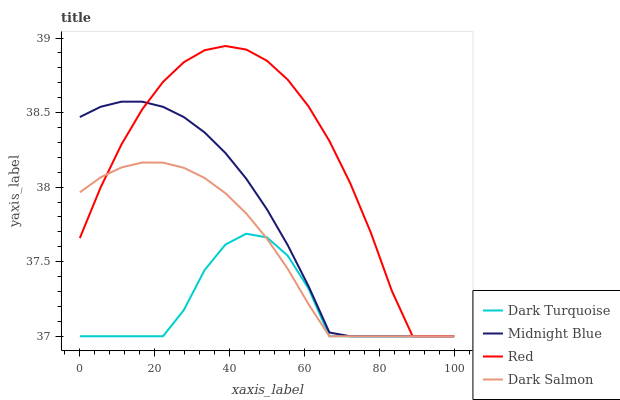Does Dark Turquoise have the minimum area under the curve?
Answer yes or no. Yes. Does Red have the maximum area under the curve?
Answer yes or no. Yes. Does Midnight Blue have the minimum area under the curve?
Answer yes or no. No. Does Midnight Blue have the maximum area under the curve?
Answer yes or no. No. Is Dark Salmon the smoothest?
Answer yes or no. Yes. Is Dark Turquoise the roughest?
Answer yes or no. Yes. Is Midnight Blue the smoothest?
Answer yes or no. No. Is Midnight Blue the roughest?
Answer yes or no. No. Does Dark Turquoise have the lowest value?
Answer yes or no. Yes. Does Red have the highest value?
Answer yes or no. Yes. Does Midnight Blue have the highest value?
Answer yes or no. No. Does Midnight Blue intersect Dark Salmon?
Answer yes or no. Yes. Is Midnight Blue less than Dark Salmon?
Answer yes or no. No. Is Midnight Blue greater than Dark Salmon?
Answer yes or no. No. 